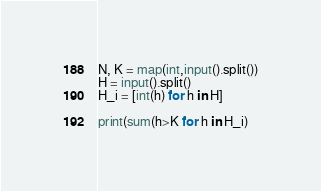<code> <loc_0><loc_0><loc_500><loc_500><_Python_>N, K = map(int,input().split())
H = input().split()
H_i = [int(h) for h in H]

print(sum(h>K for h in H_i)</code> 